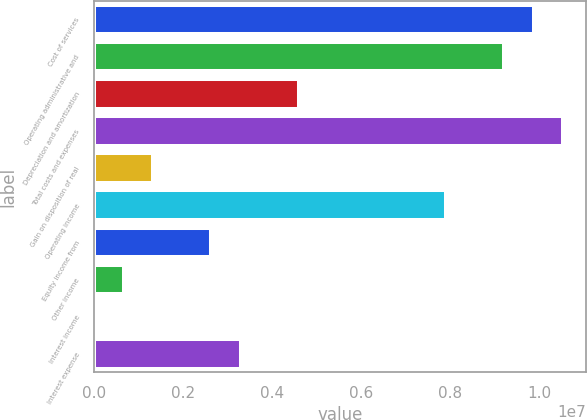<chart> <loc_0><loc_0><loc_500><loc_500><bar_chart><fcel>Cost of services<fcel>Operating administrative and<fcel>Depreciation and amortization<fcel>Total costs and expenses<fcel>Gain on disposition of real<fcel>Operating income<fcel>Equity income from<fcel>Other income<fcel>Interest income<fcel>Interest expense<nl><fcel>9.87018e+06<fcel>9.21259e+06<fcel>4.60944e+06<fcel>1.05278e+07<fcel>1.32147e+06<fcel>7.8974e+06<fcel>2.63666e+06<fcel>663882<fcel>6289<fcel>3.29425e+06<nl></chart> 